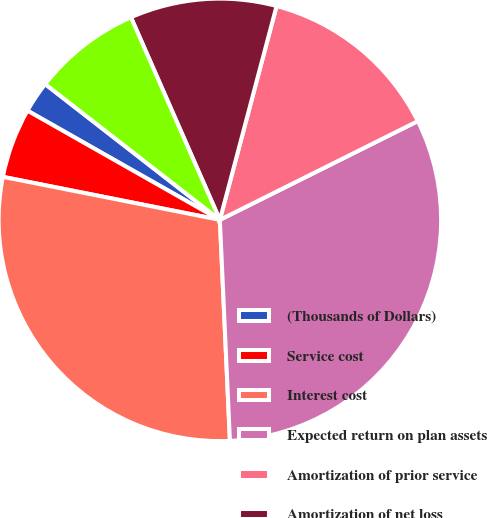Convert chart to OTSL. <chart><loc_0><loc_0><loc_500><loc_500><pie_chart><fcel>(Thousands of Dollars)<fcel>Service cost<fcel>Interest cost<fcel>Expected return on plan assets<fcel>Amortization of prior service<fcel>Amortization of net loss<fcel>Net periodic postretirement<nl><fcel>2.3%<fcel>5.1%<fcel>28.84%<fcel>31.64%<fcel>13.51%<fcel>10.71%<fcel>7.9%<nl></chart> 